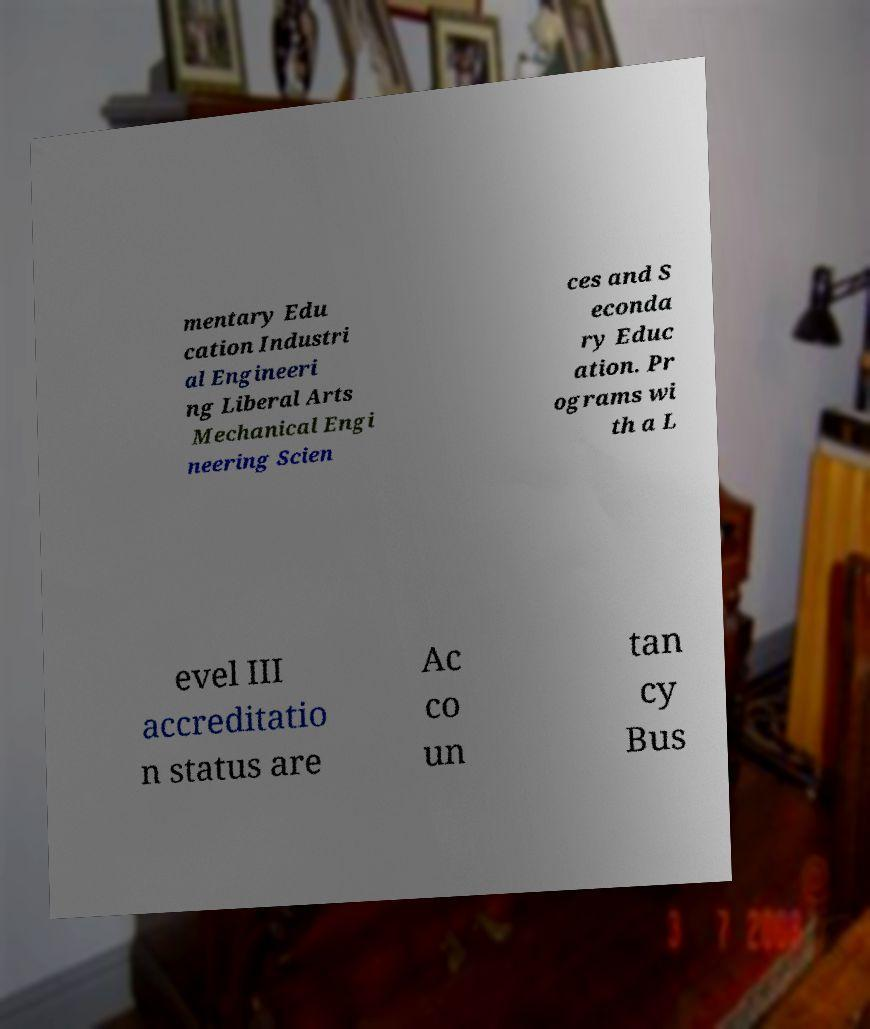Please identify and transcribe the text found in this image. mentary Edu cation Industri al Engineeri ng Liberal Arts Mechanical Engi neering Scien ces and S econda ry Educ ation. Pr ograms wi th a L evel III accreditatio n status are Ac co un tan cy Bus 